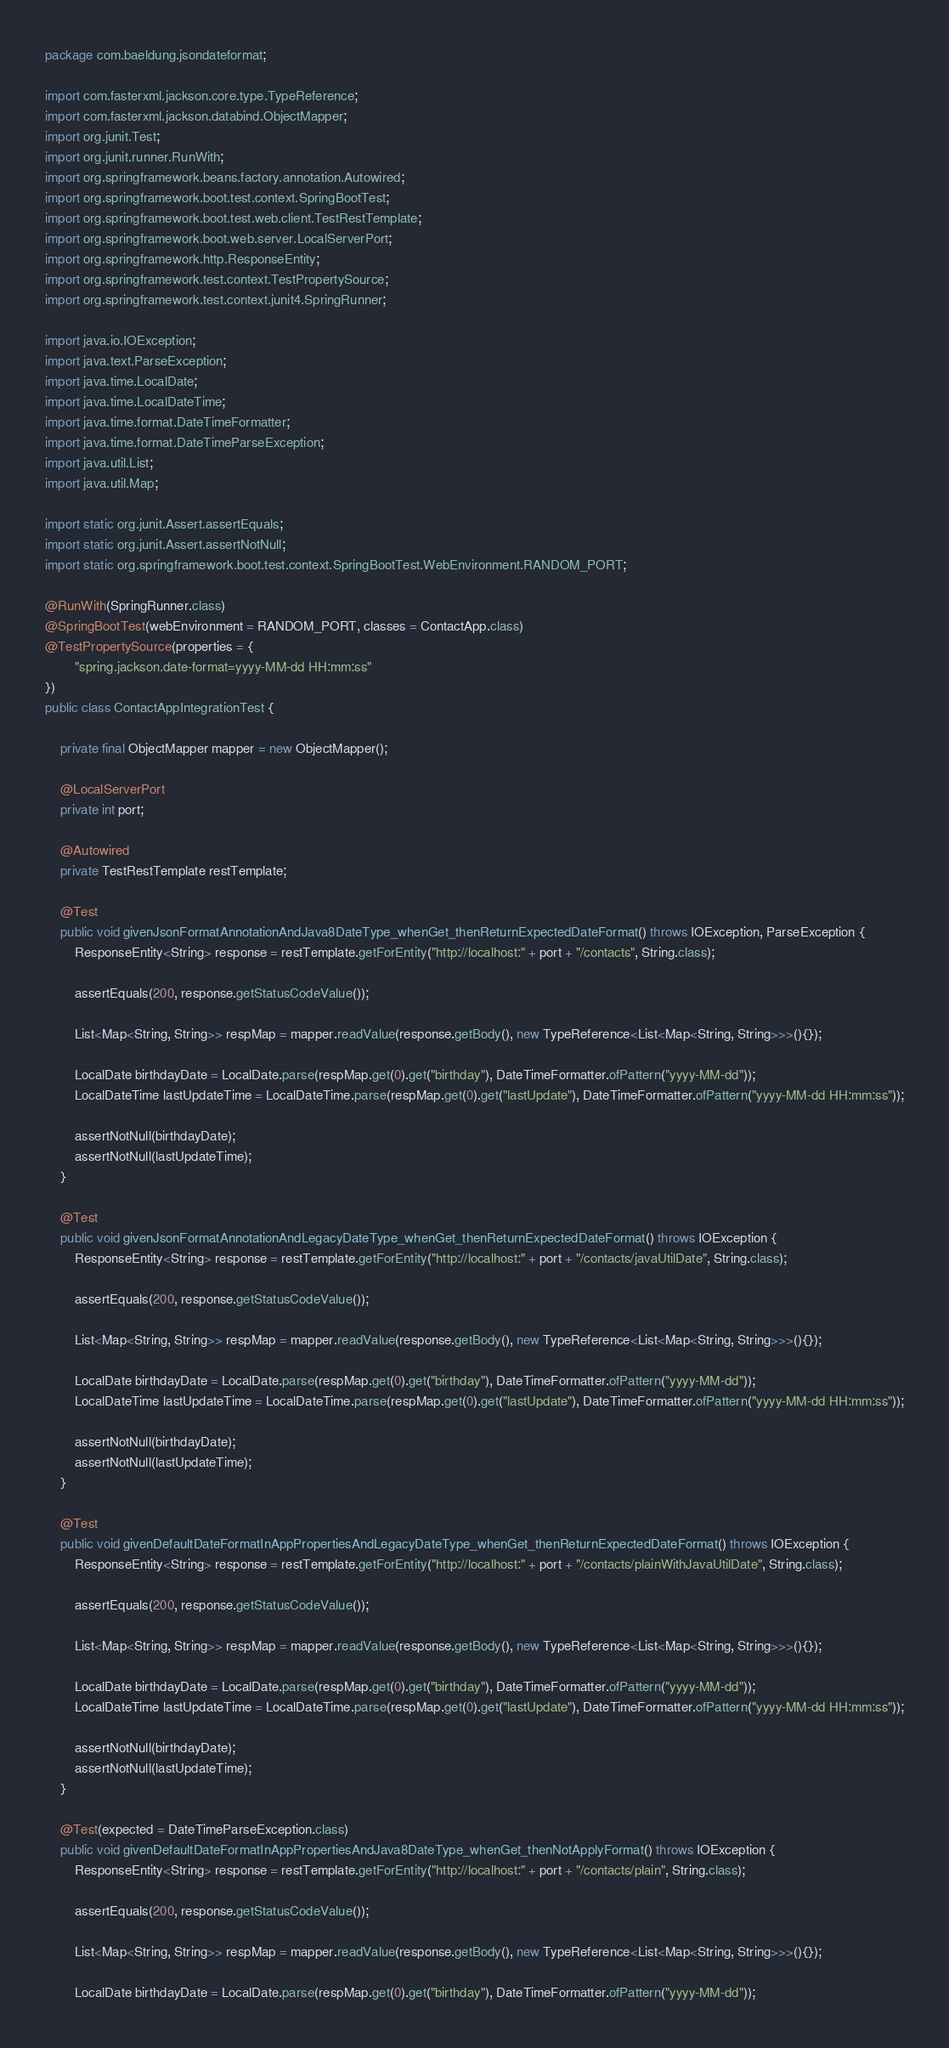<code> <loc_0><loc_0><loc_500><loc_500><_Java_>package com.baeldung.jsondateformat;

import com.fasterxml.jackson.core.type.TypeReference;
import com.fasterxml.jackson.databind.ObjectMapper;
import org.junit.Test;
import org.junit.runner.RunWith;
import org.springframework.beans.factory.annotation.Autowired;
import org.springframework.boot.test.context.SpringBootTest;
import org.springframework.boot.test.web.client.TestRestTemplate;
import org.springframework.boot.web.server.LocalServerPort;
import org.springframework.http.ResponseEntity;
import org.springframework.test.context.TestPropertySource;
import org.springframework.test.context.junit4.SpringRunner;

import java.io.IOException;
import java.text.ParseException;
import java.time.LocalDate;
import java.time.LocalDateTime;
import java.time.format.DateTimeFormatter;
import java.time.format.DateTimeParseException;
import java.util.List;
import java.util.Map;

import static org.junit.Assert.assertEquals;
import static org.junit.Assert.assertNotNull;
import static org.springframework.boot.test.context.SpringBootTest.WebEnvironment.RANDOM_PORT;

@RunWith(SpringRunner.class)
@SpringBootTest(webEnvironment = RANDOM_PORT, classes = ContactApp.class)
@TestPropertySource(properties = {
        "spring.jackson.date-format=yyyy-MM-dd HH:mm:ss"
})
public class ContactAppIntegrationTest {

    private final ObjectMapper mapper = new ObjectMapper();

    @LocalServerPort
    private int port;

    @Autowired
    private TestRestTemplate restTemplate;

    @Test
    public void givenJsonFormatAnnotationAndJava8DateType_whenGet_thenReturnExpectedDateFormat() throws IOException, ParseException {
        ResponseEntity<String> response = restTemplate.getForEntity("http://localhost:" + port + "/contacts", String.class);

        assertEquals(200, response.getStatusCodeValue());

        List<Map<String, String>> respMap = mapper.readValue(response.getBody(), new TypeReference<List<Map<String, String>>>(){});

        LocalDate birthdayDate = LocalDate.parse(respMap.get(0).get("birthday"), DateTimeFormatter.ofPattern("yyyy-MM-dd"));
        LocalDateTime lastUpdateTime = LocalDateTime.parse(respMap.get(0).get("lastUpdate"), DateTimeFormatter.ofPattern("yyyy-MM-dd HH:mm:ss"));

        assertNotNull(birthdayDate);
        assertNotNull(lastUpdateTime);
    }

    @Test
    public void givenJsonFormatAnnotationAndLegacyDateType_whenGet_thenReturnExpectedDateFormat() throws IOException {
        ResponseEntity<String> response = restTemplate.getForEntity("http://localhost:" + port + "/contacts/javaUtilDate", String.class);

        assertEquals(200, response.getStatusCodeValue());

        List<Map<String, String>> respMap = mapper.readValue(response.getBody(), new TypeReference<List<Map<String, String>>>(){});

        LocalDate birthdayDate = LocalDate.parse(respMap.get(0).get("birthday"), DateTimeFormatter.ofPattern("yyyy-MM-dd"));
        LocalDateTime lastUpdateTime = LocalDateTime.parse(respMap.get(0).get("lastUpdate"), DateTimeFormatter.ofPattern("yyyy-MM-dd HH:mm:ss"));

        assertNotNull(birthdayDate);
        assertNotNull(lastUpdateTime);
    }

    @Test
    public void givenDefaultDateFormatInAppPropertiesAndLegacyDateType_whenGet_thenReturnExpectedDateFormat() throws IOException {
        ResponseEntity<String> response = restTemplate.getForEntity("http://localhost:" + port + "/contacts/plainWithJavaUtilDate", String.class);

        assertEquals(200, response.getStatusCodeValue());

        List<Map<String, String>> respMap = mapper.readValue(response.getBody(), new TypeReference<List<Map<String, String>>>(){});

        LocalDate birthdayDate = LocalDate.parse(respMap.get(0).get("birthday"), DateTimeFormatter.ofPattern("yyyy-MM-dd"));
        LocalDateTime lastUpdateTime = LocalDateTime.parse(respMap.get(0).get("lastUpdate"), DateTimeFormatter.ofPattern("yyyy-MM-dd HH:mm:ss"));

        assertNotNull(birthdayDate);
        assertNotNull(lastUpdateTime);
    }

    @Test(expected = DateTimeParseException.class)
    public void givenDefaultDateFormatInAppPropertiesAndJava8DateType_whenGet_thenNotApplyFormat() throws IOException {
        ResponseEntity<String> response = restTemplate.getForEntity("http://localhost:" + port + "/contacts/plain", String.class);

        assertEquals(200, response.getStatusCodeValue());

        List<Map<String, String>> respMap = mapper.readValue(response.getBody(), new TypeReference<List<Map<String, String>>>(){});

        LocalDate birthdayDate = LocalDate.parse(respMap.get(0).get("birthday"), DateTimeFormatter.ofPattern("yyyy-MM-dd"));</code> 